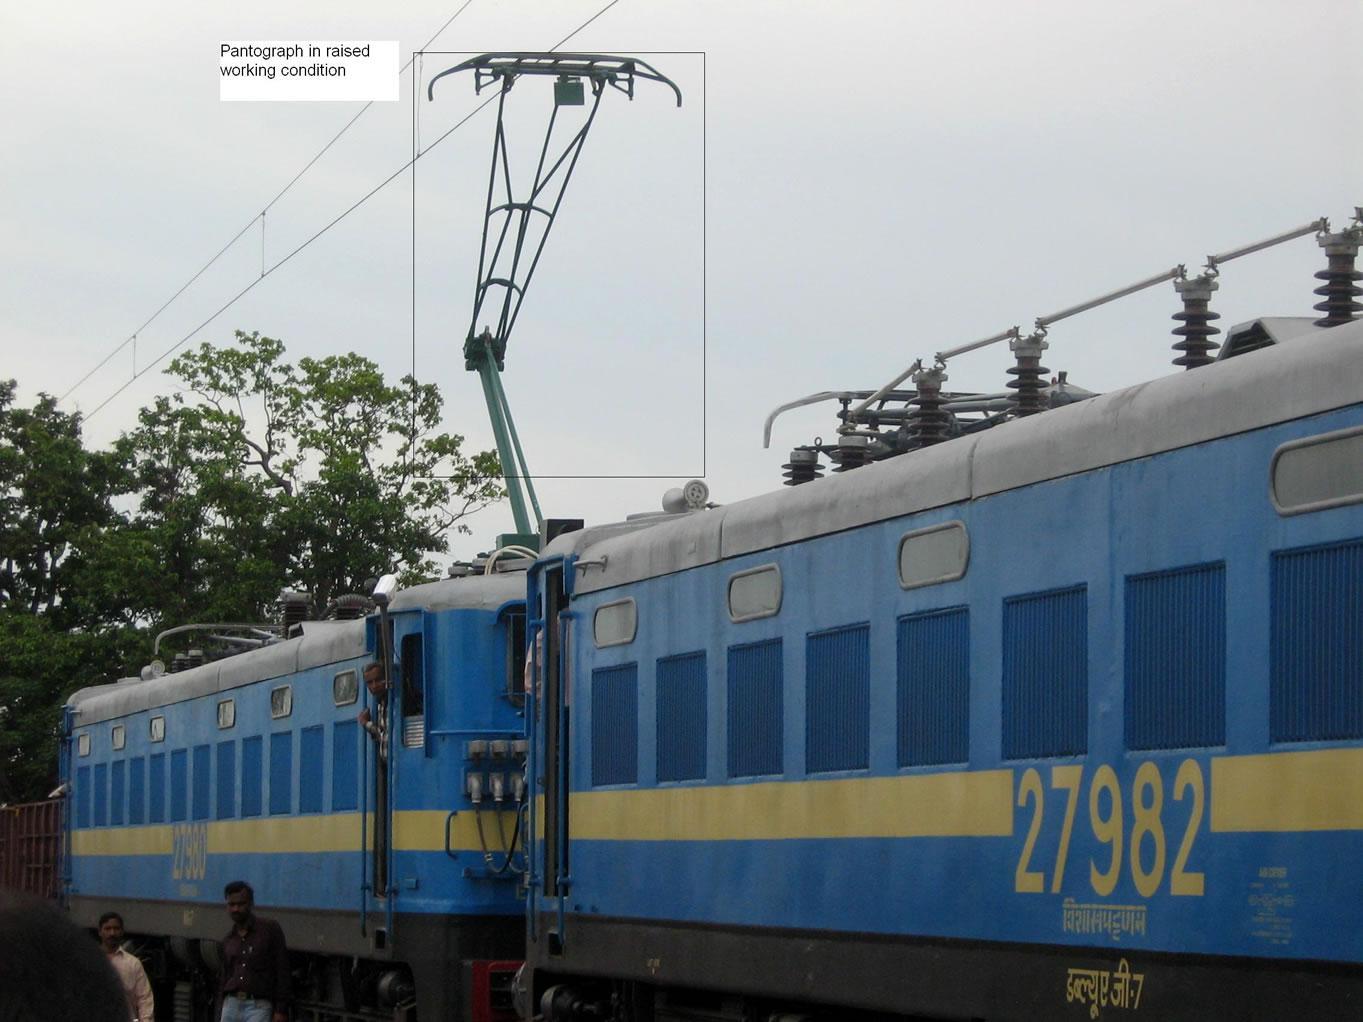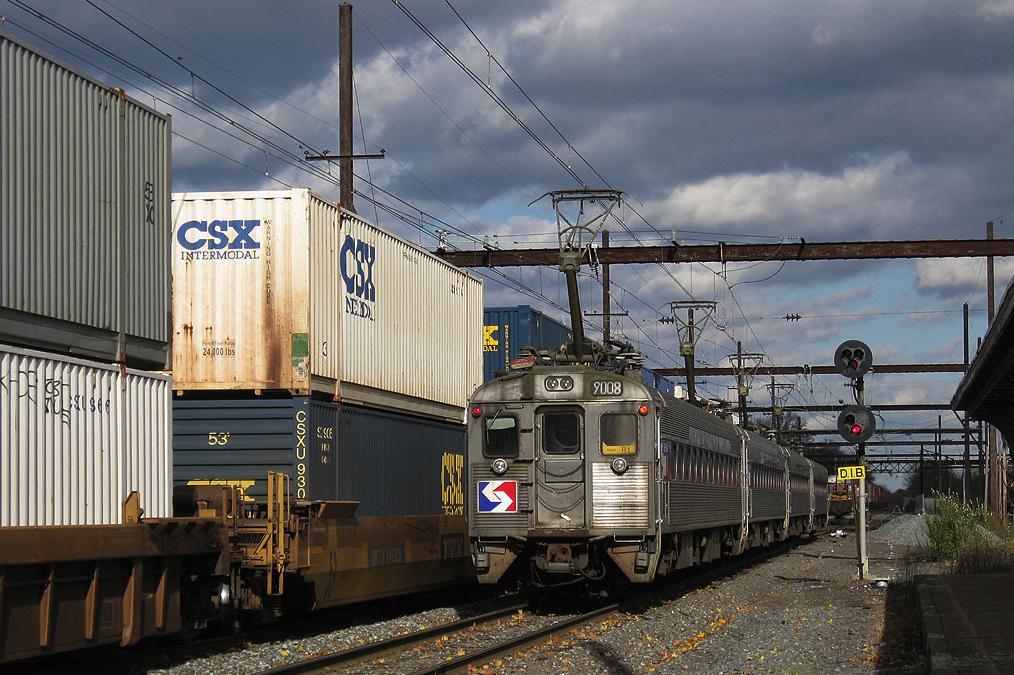The first image is the image on the left, the second image is the image on the right. Examine the images to the left and right. Is the description "One of the trains is blue with a yellow stripe on it." accurate? Answer yes or no. Yes. The first image is the image on the left, the second image is the image on the right. For the images displayed, is the sentence "An image shows an angled baby-blue train with a yellow stripe, and above the train is a hinged metal contraption." factually correct? Answer yes or no. Yes. 